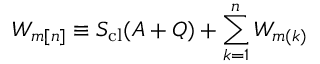<formula> <loc_0><loc_0><loc_500><loc_500>W _ { m [ n ] } \equiv S _ { c l } ( A + Q ) + \sum _ { k = 1 } ^ { n } W _ { m ( k ) }</formula> 